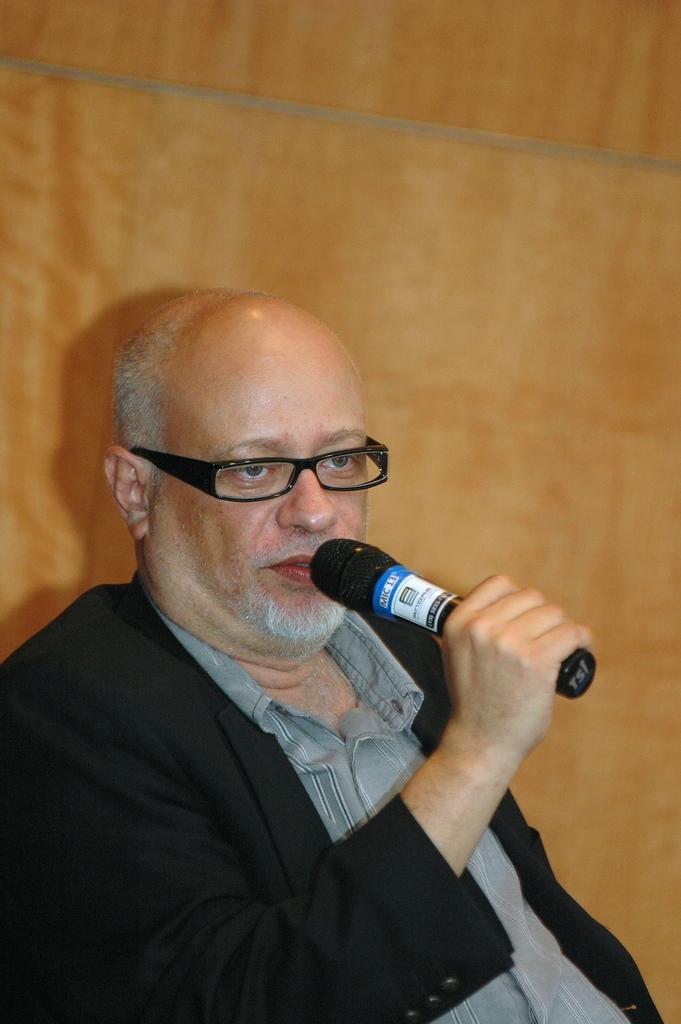Could you give a brief overview of what you see in this image? In this picture I can see a man speaking with the help of a microphone in his hand and it looks like a wooden wall in the background. 